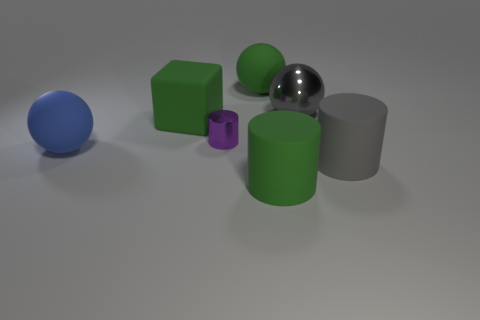There is a metal thing on the left side of the big cylinder that is left of the large gray cylinder; what is its color?
Give a very brief answer. Purple. Do the tiny purple shiny thing and the big object that is on the right side of the big gray metal ball have the same shape?
Ensure brevity in your answer.  Yes. What is the material of the green object on the left side of the large matte ball that is on the right side of the big matte sphere that is in front of the metallic ball?
Offer a terse response. Rubber. Are there any green cylinders that have the same size as the green rubber ball?
Your response must be concise. Yes. What size is the green cylinder that is the same material as the large blue ball?
Keep it short and to the point. Large. What shape is the small shiny thing?
Your response must be concise. Cylinder. Do the large green cube and the cylinder that is on the right side of the large green cylinder have the same material?
Your response must be concise. Yes. What number of objects are big gray matte things or big matte spheres?
Make the answer very short. 3. Is there a cylinder?
Give a very brief answer. Yes. There is a large matte thing right of the gray thing that is behind the purple cylinder; what shape is it?
Your answer should be very brief. Cylinder. 